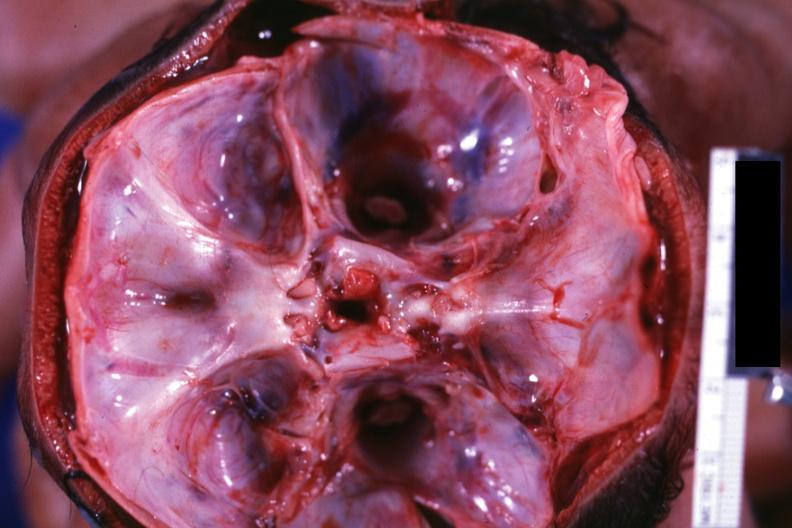s bone, skull present?
Answer the question using a single word or phrase. Yes 